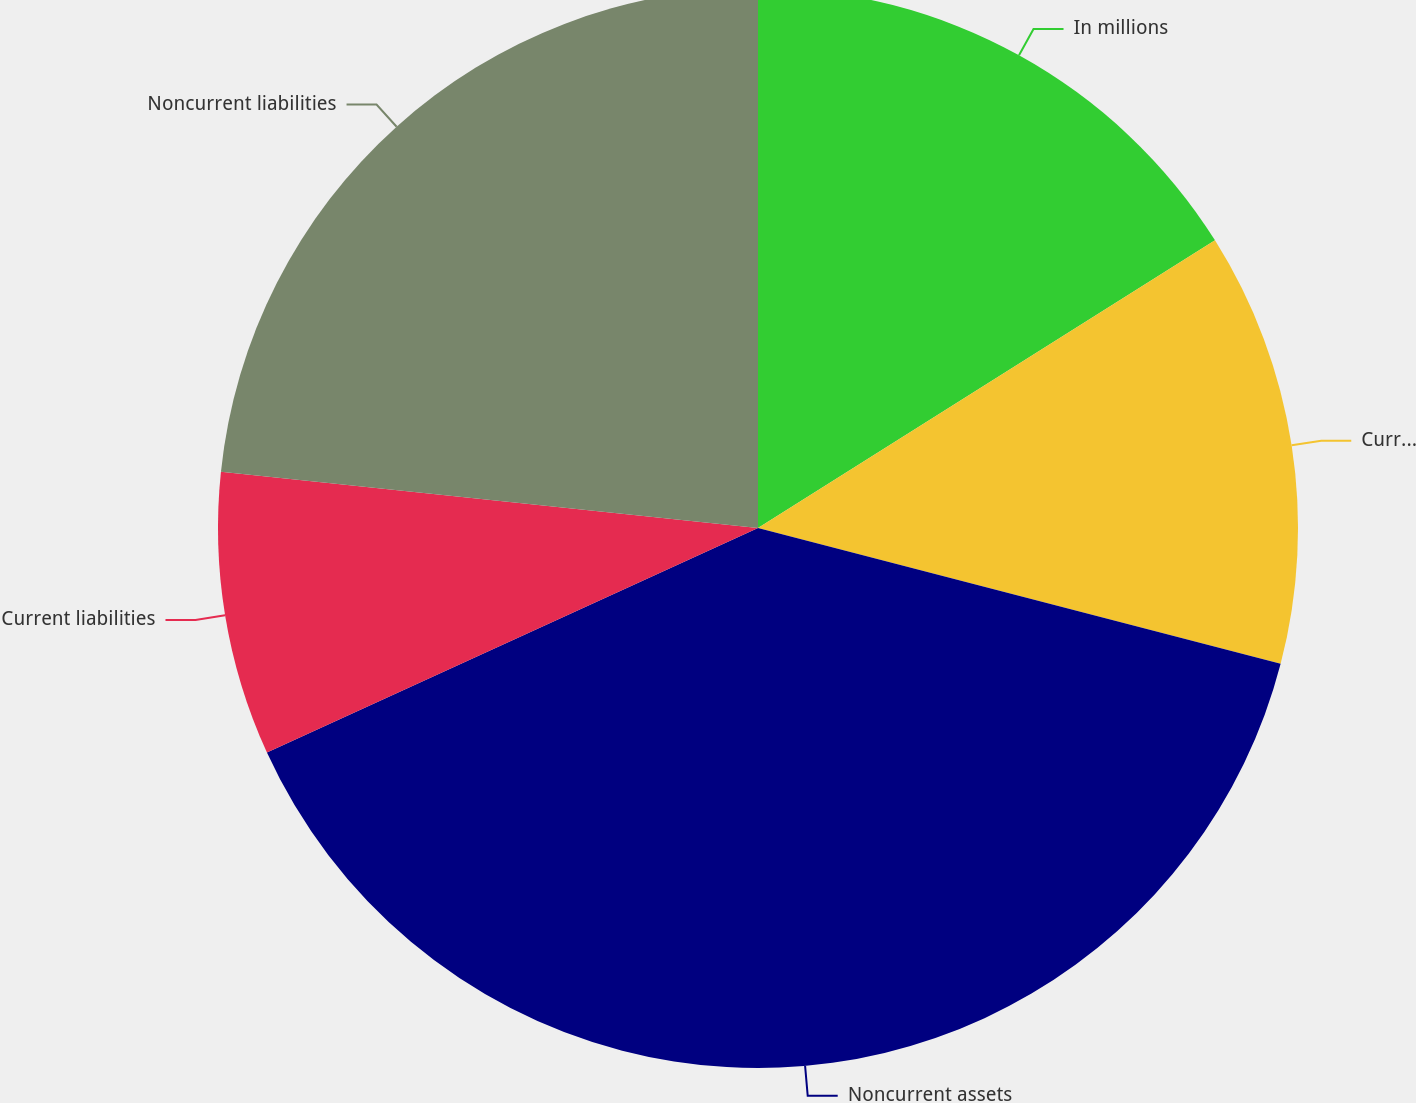<chart> <loc_0><loc_0><loc_500><loc_500><pie_chart><fcel>In millions<fcel>Current assets<fcel>Noncurrent assets<fcel>Current liabilities<fcel>Noncurrent liabilities<nl><fcel>16.06%<fcel>12.99%<fcel>39.13%<fcel>8.49%<fcel>23.34%<nl></chart> 